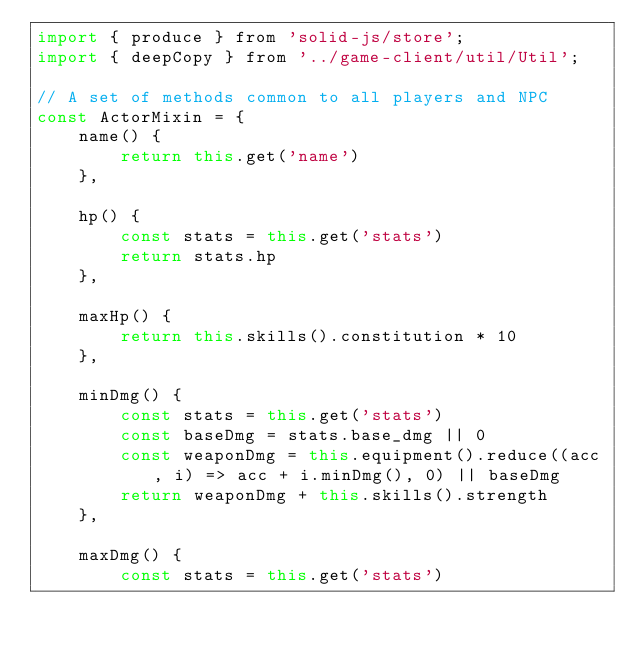Convert code to text. <code><loc_0><loc_0><loc_500><loc_500><_JavaScript_>import { produce } from 'solid-js/store';
import { deepCopy } from '../game-client/util/Util';

// A set of methods common to all players and NPC
const ActorMixin = {
    name() {
        return this.get('name')
    },

    hp() {
        const stats = this.get('stats')
        return stats.hp
    },

    maxHp() {
        return this.skills().constitution * 10
    },

    minDmg() {
        const stats = this.get('stats')
        const baseDmg = stats.base_dmg || 0
        const weaponDmg = this.equipment().reduce((acc, i) => acc + i.minDmg(), 0) || baseDmg
        return weaponDmg + this.skills().strength
    },

    maxDmg() {
        const stats = this.get('stats')</code> 